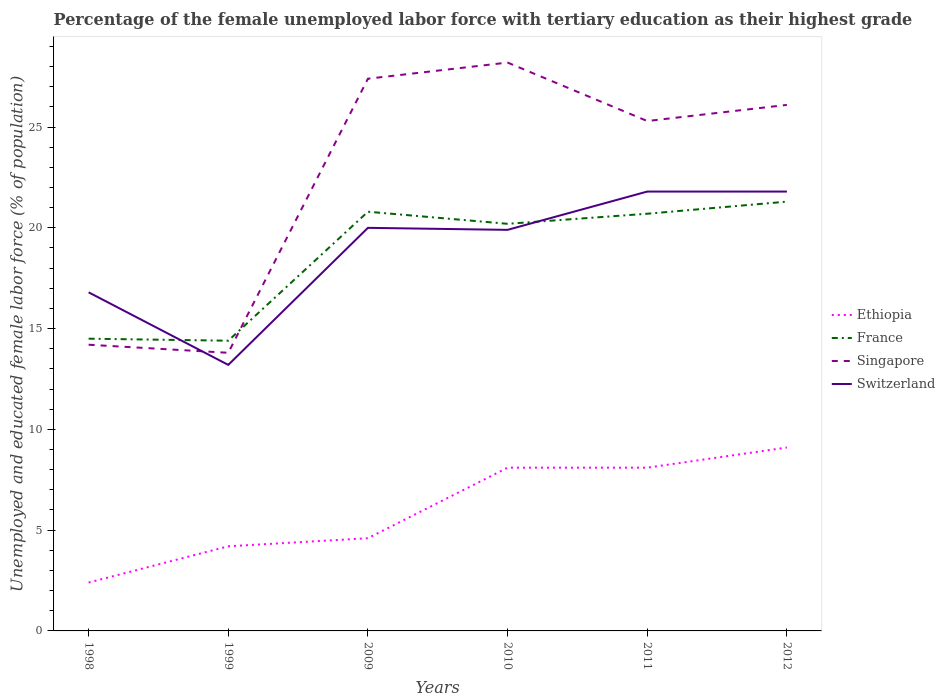Is the number of lines equal to the number of legend labels?
Ensure brevity in your answer.  Yes. Across all years, what is the maximum percentage of the unemployed female labor force with tertiary education in Singapore?
Give a very brief answer. 13.8. What is the total percentage of the unemployed female labor force with tertiary education in France in the graph?
Your answer should be compact. 0.6. What is the difference between the highest and the second highest percentage of the unemployed female labor force with tertiary education in Ethiopia?
Provide a succinct answer. 6.7. Is the percentage of the unemployed female labor force with tertiary education in Singapore strictly greater than the percentage of the unemployed female labor force with tertiary education in France over the years?
Provide a short and direct response. No. What is the difference between two consecutive major ticks on the Y-axis?
Give a very brief answer. 5. How many legend labels are there?
Make the answer very short. 4. How are the legend labels stacked?
Keep it short and to the point. Vertical. What is the title of the graph?
Provide a short and direct response. Percentage of the female unemployed labor force with tertiary education as their highest grade. Does "Mali" appear as one of the legend labels in the graph?
Your answer should be compact. No. What is the label or title of the X-axis?
Your response must be concise. Years. What is the label or title of the Y-axis?
Offer a terse response. Unemployed and educated female labor force (% of population). What is the Unemployed and educated female labor force (% of population) of Ethiopia in 1998?
Offer a terse response. 2.4. What is the Unemployed and educated female labor force (% of population) in France in 1998?
Offer a terse response. 14.5. What is the Unemployed and educated female labor force (% of population) in Singapore in 1998?
Your answer should be compact. 14.2. What is the Unemployed and educated female labor force (% of population) of Switzerland in 1998?
Make the answer very short. 16.8. What is the Unemployed and educated female labor force (% of population) of Ethiopia in 1999?
Your answer should be very brief. 4.2. What is the Unemployed and educated female labor force (% of population) in France in 1999?
Provide a succinct answer. 14.4. What is the Unemployed and educated female labor force (% of population) of Singapore in 1999?
Offer a very short reply. 13.8. What is the Unemployed and educated female labor force (% of population) of Switzerland in 1999?
Provide a succinct answer. 13.2. What is the Unemployed and educated female labor force (% of population) of Ethiopia in 2009?
Your answer should be very brief. 4.6. What is the Unemployed and educated female labor force (% of population) in France in 2009?
Keep it short and to the point. 20.8. What is the Unemployed and educated female labor force (% of population) in Singapore in 2009?
Your answer should be very brief. 27.4. What is the Unemployed and educated female labor force (% of population) of Switzerland in 2009?
Your answer should be compact. 20. What is the Unemployed and educated female labor force (% of population) in Ethiopia in 2010?
Ensure brevity in your answer.  8.1. What is the Unemployed and educated female labor force (% of population) in France in 2010?
Make the answer very short. 20.2. What is the Unemployed and educated female labor force (% of population) of Singapore in 2010?
Offer a very short reply. 28.2. What is the Unemployed and educated female labor force (% of population) of Switzerland in 2010?
Offer a very short reply. 19.9. What is the Unemployed and educated female labor force (% of population) of Ethiopia in 2011?
Provide a short and direct response. 8.1. What is the Unemployed and educated female labor force (% of population) of France in 2011?
Provide a short and direct response. 20.7. What is the Unemployed and educated female labor force (% of population) of Singapore in 2011?
Ensure brevity in your answer.  25.3. What is the Unemployed and educated female labor force (% of population) of Switzerland in 2011?
Keep it short and to the point. 21.8. What is the Unemployed and educated female labor force (% of population) of Ethiopia in 2012?
Provide a short and direct response. 9.1. What is the Unemployed and educated female labor force (% of population) in France in 2012?
Offer a very short reply. 21.3. What is the Unemployed and educated female labor force (% of population) in Singapore in 2012?
Keep it short and to the point. 26.1. What is the Unemployed and educated female labor force (% of population) in Switzerland in 2012?
Provide a succinct answer. 21.8. Across all years, what is the maximum Unemployed and educated female labor force (% of population) in Ethiopia?
Offer a very short reply. 9.1. Across all years, what is the maximum Unemployed and educated female labor force (% of population) in France?
Offer a terse response. 21.3. Across all years, what is the maximum Unemployed and educated female labor force (% of population) in Singapore?
Make the answer very short. 28.2. Across all years, what is the maximum Unemployed and educated female labor force (% of population) in Switzerland?
Provide a succinct answer. 21.8. Across all years, what is the minimum Unemployed and educated female labor force (% of population) in Ethiopia?
Offer a very short reply. 2.4. Across all years, what is the minimum Unemployed and educated female labor force (% of population) of France?
Provide a succinct answer. 14.4. Across all years, what is the minimum Unemployed and educated female labor force (% of population) in Singapore?
Offer a very short reply. 13.8. Across all years, what is the minimum Unemployed and educated female labor force (% of population) of Switzerland?
Your answer should be very brief. 13.2. What is the total Unemployed and educated female labor force (% of population) of Ethiopia in the graph?
Give a very brief answer. 36.5. What is the total Unemployed and educated female labor force (% of population) of France in the graph?
Ensure brevity in your answer.  111.9. What is the total Unemployed and educated female labor force (% of population) in Singapore in the graph?
Ensure brevity in your answer.  135. What is the total Unemployed and educated female labor force (% of population) of Switzerland in the graph?
Ensure brevity in your answer.  113.5. What is the difference between the Unemployed and educated female labor force (% of population) of Ethiopia in 1998 and that in 1999?
Ensure brevity in your answer.  -1.8. What is the difference between the Unemployed and educated female labor force (% of population) of Ethiopia in 1998 and that in 2009?
Ensure brevity in your answer.  -2.2. What is the difference between the Unemployed and educated female labor force (% of population) in France in 1998 and that in 2009?
Your answer should be very brief. -6.3. What is the difference between the Unemployed and educated female labor force (% of population) of Switzerland in 1998 and that in 2009?
Your answer should be very brief. -3.2. What is the difference between the Unemployed and educated female labor force (% of population) in Ethiopia in 1998 and that in 2010?
Give a very brief answer. -5.7. What is the difference between the Unemployed and educated female labor force (% of population) in France in 1998 and that in 2010?
Provide a succinct answer. -5.7. What is the difference between the Unemployed and educated female labor force (% of population) of Switzerland in 1998 and that in 2010?
Make the answer very short. -3.1. What is the difference between the Unemployed and educated female labor force (% of population) in Ethiopia in 1998 and that in 2011?
Keep it short and to the point. -5.7. What is the difference between the Unemployed and educated female labor force (% of population) in Singapore in 1998 and that in 2011?
Offer a very short reply. -11.1. What is the difference between the Unemployed and educated female labor force (% of population) of Singapore in 1998 and that in 2012?
Provide a succinct answer. -11.9. What is the difference between the Unemployed and educated female labor force (% of population) of Ethiopia in 1999 and that in 2009?
Your answer should be very brief. -0.4. What is the difference between the Unemployed and educated female labor force (% of population) in France in 1999 and that in 2009?
Give a very brief answer. -6.4. What is the difference between the Unemployed and educated female labor force (% of population) of Singapore in 1999 and that in 2009?
Offer a very short reply. -13.6. What is the difference between the Unemployed and educated female labor force (% of population) of Ethiopia in 1999 and that in 2010?
Provide a short and direct response. -3.9. What is the difference between the Unemployed and educated female labor force (% of population) of Singapore in 1999 and that in 2010?
Offer a very short reply. -14.4. What is the difference between the Unemployed and educated female labor force (% of population) in Singapore in 1999 and that in 2011?
Keep it short and to the point. -11.5. What is the difference between the Unemployed and educated female labor force (% of population) in France in 1999 and that in 2012?
Your answer should be compact. -6.9. What is the difference between the Unemployed and educated female labor force (% of population) of Switzerland in 1999 and that in 2012?
Give a very brief answer. -8.6. What is the difference between the Unemployed and educated female labor force (% of population) of Ethiopia in 2009 and that in 2010?
Offer a terse response. -3.5. What is the difference between the Unemployed and educated female labor force (% of population) of France in 2009 and that in 2010?
Your response must be concise. 0.6. What is the difference between the Unemployed and educated female labor force (% of population) of Switzerland in 2009 and that in 2010?
Keep it short and to the point. 0.1. What is the difference between the Unemployed and educated female labor force (% of population) in Ethiopia in 2009 and that in 2011?
Provide a succinct answer. -3.5. What is the difference between the Unemployed and educated female labor force (% of population) of Singapore in 2009 and that in 2011?
Offer a very short reply. 2.1. What is the difference between the Unemployed and educated female labor force (% of population) of Switzerland in 2009 and that in 2011?
Provide a short and direct response. -1.8. What is the difference between the Unemployed and educated female labor force (% of population) of Ethiopia in 2009 and that in 2012?
Ensure brevity in your answer.  -4.5. What is the difference between the Unemployed and educated female labor force (% of population) of France in 2009 and that in 2012?
Offer a terse response. -0.5. What is the difference between the Unemployed and educated female labor force (% of population) of Singapore in 2009 and that in 2012?
Offer a very short reply. 1.3. What is the difference between the Unemployed and educated female labor force (% of population) in Ethiopia in 2010 and that in 2011?
Your answer should be compact. 0. What is the difference between the Unemployed and educated female labor force (% of population) of France in 2010 and that in 2011?
Ensure brevity in your answer.  -0.5. What is the difference between the Unemployed and educated female labor force (% of population) of Switzerland in 2010 and that in 2011?
Keep it short and to the point. -1.9. What is the difference between the Unemployed and educated female labor force (% of population) in Singapore in 2010 and that in 2012?
Provide a short and direct response. 2.1. What is the difference between the Unemployed and educated female labor force (% of population) of Switzerland in 2011 and that in 2012?
Provide a succinct answer. 0. What is the difference between the Unemployed and educated female labor force (% of population) of Singapore in 1998 and the Unemployed and educated female labor force (% of population) of Switzerland in 1999?
Offer a very short reply. 1. What is the difference between the Unemployed and educated female labor force (% of population) in Ethiopia in 1998 and the Unemployed and educated female labor force (% of population) in France in 2009?
Offer a terse response. -18.4. What is the difference between the Unemployed and educated female labor force (% of population) of Ethiopia in 1998 and the Unemployed and educated female labor force (% of population) of Switzerland in 2009?
Ensure brevity in your answer.  -17.6. What is the difference between the Unemployed and educated female labor force (% of population) of Ethiopia in 1998 and the Unemployed and educated female labor force (% of population) of France in 2010?
Keep it short and to the point. -17.8. What is the difference between the Unemployed and educated female labor force (% of population) of Ethiopia in 1998 and the Unemployed and educated female labor force (% of population) of Singapore in 2010?
Your answer should be very brief. -25.8. What is the difference between the Unemployed and educated female labor force (% of population) of Ethiopia in 1998 and the Unemployed and educated female labor force (% of population) of Switzerland in 2010?
Give a very brief answer. -17.5. What is the difference between the Unemployed and educated female labor force (% of population) in France in 1998 and the Unemployed and educated female labor force (% of population) in Singapore in 2010?
Give a very brief answer. -13.7. What is the difference between the Unemployed and educated female labor force (% of population) in Singapore in 1998 and the Unemployed and educated female labor force (% of population) in Switzerland in 2010?
Ensure brevity in your answer.  -5.7. What is the difference between the Unemployed and educated female labor force (% of population) of Ethiopia in 1998 and the Unemployed and educated female labor force (% of population) of France in 2011?
Keep it short and to the point. -18.3. What is the difference between the Unemployed and educated female labor force (% of population) of Ethiopia in 1998 and the Unemployed and educated female labor force (% of population) of Singapore in 2011?
Keep it short and to the point. -22.9. What is the difference between the Unemployed and educated female labor force (% of population) in Ethiopia in 1998 and the Unemployed and educated female labor force (% of population) in Switzerland in 2011?
Your answer should be compact. -19.4. What is the difference between the Unemployed and educated female labor force (% of population) in France in 1998 and the Unemployed and educated female labor force (% of population) in Singapore in 2011?
Ensure brevity in your answer.  -10.8. What is the difference between the Unemployed and educated female labor force (% of population) in France in 1998 and the Unemployed and educated female labor force (% of population) in Switzerland in 2011?
Your response must be concise. -7.3. What is the difference between the Unemployed and educated female labor force (% of population) of Ethiopia in 1998 and the Unemployed and educated female labor force (% of population) of France in 2012?
Offer a very short reply. -18.9. What is the difference between the Unemployed and educated female labor force (% of population) in Ethiopia in 1998 and the Unemployed and educated female labor force (% of population) in Singapore in 2012?
Your response must be concise. -23.7. What is the difference between the Unemployed and educated female labor force (% of population) of Ethiopia in 1998 and the Unemployed and educated female labor force (% of population) of Switzerland in 2012?
Offer a terse response. -19.4. What is the difference between the Unemployed and educated female labor force (% of population) of Ethiopia in 1999 and the Unemployed and educated female labor force (% of population) of France in 2009?
Give a very brief answer. -16.6. What is the difference between the Unemployed and educated female labor force (% of population) in Ethiopia in 1999 and the Unemployed and educated female labor force (% of population) in Singapore in 2009?
Give a very brief answer. -23.2. What is the difference between the Unemployed and educated female labor force (% of population) of Ethiopia in 1999 and the Unemployed and educated female labor force (% of population) of Switzerland in 2009?
Your response must be concise. -15.8. What is the difference between the Unemployed and educated female labor force (% of population) of France in 1999 and the Unemployed and educated female labor force (% of population) of Singapore in 2009?
Ensure brevity in your answer.  -13. What is the difference between the Unemployed and educated female labor force (% of population) of Singapore in 1999 and the Unemployed and educated female labor force (% of population) of Switzerland in 2009?
Keep it short and to the point. -6.2. What is the difference between the Unemployed and educated female labor force (% of population) in Ethiopia in 1999 and the Unemployed and educated female labor force (% of population) in Singapore in 2010?
Offer a terse response. -24. What is the difference between the Unemployed and educated female labor force (% of population) of Ethiopia in 1999 and the Unemployed and educated female labor force (% of population) of Switzerland in 2010?
Give a very brief answer. -15.7. What is the difference between the Unemployed and educated female labor force (% of population) of France in 1999 and the Unemployed and educated female labor force (% of population) of Singapore in 2010?
Your answer should be compact. -13.8. What is the difference between the Unemployed and educated female labor force (% of population) in Ethiopia in 1999 and the Unemployed and educated female labor force (% of population) in France in 2011?
Provide a succinct answer. -16.5. What is the difference between the Unemployed and educated female labor force (% of population) of Ethiopia in 1999 and the Unemployed and educated female labor force (% of population) of Singapore in 2011?
Your answer should be very brief. -21.1. What is the difference between the Unemployed and educated female labor force (% of population) of Ethiopia in 1999 and the Unemployed and educated female labor force (% of population) of Switzerland in 2011?
Provide a short and direct response. -17.6. What is the difference between the Unemployed and educated female labor force (% of population) of France in 1999 and the Unemployed and educated female labor force (% of population) of Singapore in 2011?
Make the answer very short. -10.9. What is the difference between the Unemployed and educated female labor force (% of population) in France in 1999 and the Unemployed and educated female labor force (% of population) in Switzerland in 2011?
Provide a succinct answer. -7.4. What is the difference between the Unemployed and educated female labor force (% of population) of Singapore in 1999 and the Unemployed and educated female labor force (% of population) of Switzerland in 2011?
Your response must be concise. -8. What is the difference between the Unemployed and educated female labor force (% of population) in Ethiopia in 1999 and the Unemployed and educated female labor force (% of population) in France in 2012?
Give a very brief answer. -17.1. What is the difference between the Unemployed and educated female labor force (% of population) of Ethiopia in 1999 and the Unemployed and educated female labor force (% of population) of Singapore in 2012?
Keep it short and to the point. -21.9. What is the difference between the Unemployed and educated female labor force (% of population) in Ethiopia in 1999 and the Unemployed and educated female labor force (% of population) in Switzerland in 2012?
Give a very brief answer. -17.6. What is the difference between the Unemployed and educated female labor force (% of population) in France in 1999 and the Unemployed and educated female labor force (% of population) in Switzerland in 2012?
Keep it short and to the point. -7.4. What is the difference between the Unemployed and educated female labor force (% of population) of Ethiopia in 2009 and the Unemployed and educated female labor force (% of population) of France in 2010?
Ensure brevity in your answer.  -15.6. What is the difference between the Unemployed and educated female labor force (% of population) of Ethiopia in 2009 and the Unemployed and educated female labor force (% of population) of Singapore in 2010?
Your response must be concise. -23.6. What is the difference between the Unemployed and educated female labor force (% of population) in Ethiopia in 2009 and the Unemployed and educated female labor force (% of population) in Switzerland in 2010?
Offer a very short reply. -15.3. What is the difference between the Unemployed and educated female labor force (% of population) in France in 2009 and the Unemployed and educated female labor force (% of population) in Singapore in 2010?
Give a very brief answer. -7.4. What is the difference between the Unemployed and educated female labor force (% of population) of Singapore in 2009 and the Unemployed and educated female labor force (% of population) of Switzerland in 2010?
Your response must be concise. 7.5. What is the difference between the Unemployed and educated female labor force (% of population) in Ethiopia in 2009 and the Unemployed and educated female labor force (% of population) in France in 2011?
Your answer should be very brief. -16.1. What is the difference between the Unemployed and educated female labor force (% of population) of Ethiopia in 2009 and the Unemployed and educated female labor force (% of population) of Singapore in 2011?
Offer a very short reply. -20.7. What is the difference between the Unemployed and educated female labor force (% of population) in Ethiopia in 2009 and the Unemployed and educated female labor force (% of population) in Switzerland in 2011?
Keep it short and to the point. -17.2. What is the difference between the Unemployed and educated female labor force (% of population) of France in 2009 and the Unemployed and educated female labor force (% of population) of Singapore in 2011?
Provide a short and direct response. -4.5. What is the difference between the Unemployed and educated female labor force (% of population) of France in 2009 and the Unemployed and educated female labor force (% of population) of Switzerland in 2011?
Make the answer very short. -1. What is the difference between the Unemployed and educated female labor force (% of population) in Singapore in 2009 and the Unemployed and educated female labor force (% of population) in Switzerland in 2011?
Your answer should be very brief. 5.6. What is the difference between the Unemployed and educated female labor force (% of population) of Ethiopia in 2009 and the Unemployed and educated female labor force (% of population) of France in 2012?
Offer a terse response. -16.7. What is the difference between the Unemployed and educated female labor force (% of population) in Ethiopia in 2009 and the Unemployed and educated female labor force (% of population) in Singapore in 2012?
Provide a short and direct response. -21.5. What is the difference between the Unemployed and educated female labor force (% of population) of Ethiopia in 2009 and the Unemployed and educated female labor force (% of population) of Switzerland in 2012?
Offer a very short reply. -17.2. What is the difference between the Unemployed and educated female labor force (% of population) in Singapore in 2009 and the Unemployed and educated female labor force (% of population) in Switzerland in 2012?
Offer a very short reply. 5.6. What is the difference between the Unemployed and educated female labor force (% of population) of Ethiopia in 2010 and the Unemployed and educated female labor force (% of population) of Singapore in 2011?
Ensure brevity in your answer.  -17.2. What is the difference between the Unemployed and educated female labor force (% of population) of Ethiopia in 2010 and the Unemployed and educated female labor force (% of population) of Switzerland in 2011?
Your answer should be compact. -13.7. What is the difference between the Unemployed and educated female labor force (% of population) of Singapore in 2010 and the Unemployed and educated female labor force (% of population) of Switzerland in 2011?
Your answer should be compact. 6.4. What is the difference between the Unemployed and educated female labor force (% of population) of Ethiopia in 2010 and the Unemployed and educated female labor force (% of population) of France in 2012?
Offer a terse response. -13.2. What is the difference between the Unemployed and educated female labor force (% of population) of Ethiopia in 2010 and the Unemployed and educated female labor force (% of population) of Singapore in 2012?
Keep it short and to the point. -18. What is the difference between the Unemployed and educated female labor force (% of population) in Ethiopia in 2010 and the Unemployed and educated female labor force (% of population) in Switzerland in 2012?
Your response must be concise. -13.7. What is the difference between the Unemployed and educated female labor force (% of population) of France in 2010 and the Unemployed and educated female labor force (% of population) of Switzerland in 2012?
Offer a very short reply. -1.6. What is the difference between the Unemployed and educated female labor force (% of population) in Ethiopia in 2011 and the Unemployed and educated female labor force (% of population) in France in 2012?
Provide a short and direct response. -13.2. What is the difference between the Unemployed and educated female labor force (% of population) of Ethiopia in 2011 and the Unemployed and educated female labor force (% of population) of Switzerland in 2012?
Give a very brief answer. -13.7. What is the average Unemployed and educated female labor force (% of population) in Ethiopia per year?
Provide a succinct answer. 6.08. What is the average Unemployed and educated female labor force (% of population) in France per year?
Ensure brevity in your answer.  18.65. What is the average Unemployed and educated female labor force (% of population) in Singapore per year?
Your answer should be very brief. 22.5. What is the average Unemployed and educated female labor force (% of population) in Switzerland per year?
Offer a terse response. 18.92. In the year 1998, what is the difference between the Unemployed and educated female labor force (% of population) of Ethiopia and Unemployed and educated female labor force (% of population) of Singapore?
Offer a very short reply. -11.8. In the year 1998, what is the difference between the Unemployed and educated female labor force (% of population) of Ethiopia and Unemployed and educated female labor force (% of population) of Switzerland?
Ensure brevity in your answer.  -14.4. In the year 1998, what is the difference between the Unemployed and educated female labor force (% of population) in France and Unemployed and educated female labor force (% of population) in Singapore?
Your answer should be very brief. 0.3. In the year 1998, what is the difference between the Unemployed and educated female labor force (% of population) of Singapore and Unemployed and educated female labor force (% of population) of Switzerland?
Ensure brevity in your answer.  -2.6. In the year 1999, what is the difference between the Unemployed and educated female labor force (% of population) in Singapore and Unemployed and educated female labor force (% of population) in Switzerland?
Provide a succinct answer. 0.6. In the year 2009, what is the difference between the Unemployed and educated female labor force (% of population) in Ethiopia and Unemployed and educated female labor force (% of population) in France?
Make the answer very short. -16.2. In the year 2009, what is the difference between the Unemployed and educated female labor force (% of population) of Ethiopia and Unemployed and educated female labor force (% of population) of Singapore?
Provide a short and direct response. -22.8. In the year 2009, what is the difference between the Unemployed and educated female labor force (% of population) of Ethiopia and Unemployed and educated female labor force (% of population) of Switzerland?
Ensure brevity in your answer.  -15.4. In the year 2009, what is the difference between the Unemployed and educated female labor force (% of population) in France and Unemployed and educated female labor force (% of population) in Singapore?
Make the answer very short. -6.6. In the year 2009, what is the difference between the Unemployed and educated female labor force (% of population) of France and Unemployed and educated female labor force (% of population) of Switzerland?
Ensure brevity in your answer.  0.8. In the year 2010, what is the difference between the Unemployed and educated female labor force (% of population) in Ethiopia and Unemployed and educated female labor force (% of population) in France?
Your answer should be very brief. -12.1. In the year 2010, what is the difference between the Unemployed and educated female labor force (% of population) of Ethiopia and Unemployed and educated female labor force (% of population) of Singapore?
Make the answer very short. -20.1. In the year 2011, what is the difference between the Unemployed and educated female labor force (% of population) in Ethiopia and Unemployed and educated female labor force (% of population) in Singapore?
Provide a short and direct response. -17.2. In the year 2011, what is the difference between the Unemployed and educated female labor force (% of population) of Ethiopia and Unemployed and educated female labor force (% of population) of Switzerland?
Offer a terse response. -13.7. In the year 2011, what is the difference between the Unemployed and educated female labor force (% of population) in France and Unemployed and educated female labor force (% of population) in Singapore?
Keep it short and to the point. -4.6. In the year 2011, what is the difference between the Unemployed and educated female labor force (% of population) of Singapore and Unemployed and educated female labor force (% of population) of Switzerland?
Your response must be concise. 3.5. In the year 2012, what is the difference between the Unemployed and educated female labor force (% of population) in Ethiopia and Unemployed and educated female labor force (% of population) in Singapore?
Your answer should be very brief. -17. In the year 2012, what is the difference between the Unemployed and educated female labor force (% of population) of Ethiopia and Unemployed and educated female labor force (% of population) of Switzerland?
Your answer should be compact. -12.7. In the year 2012, what is the difference between the Unemployed and educated female labor force (% of population) of France and Unemployed and educated female labor force (% of population) of Switzerland?
Your answer should be very brief. -0.5. In the year 2012, what is the difference between the Unemployed and educated female labor force (% of population) of Singapore and Unemployed and educated female labor force (% of population) of Switzerland?
Offer a very short reply. 4.3. What is the ratio of the Unemployed and educated female labor force (% of population) of Switzerland in 1998 to that in 1999?
Keep it short and to the point. 1.27. What is the ratio of the Unemployed and educated female labor force (% of population) of Ethiopia in 1998 to that in 2009?
Offer a very short reply. 0.52. What is the ratio of the Unemployed and educated female labor force (% of population) of France in 1998 to that in 2009?
Provide a short and direct response. 0.7. What is the ratio of the Unemployed and educated female labor force (% of population) of Singapore in 1998 to that in 2009?
Offer a terse response. 0.52. What is the ratio of the Unemployed and educated female labor force (% of population) in Switzerland in 1998 to that in 2009?
Keep it short and to the point. 0.84. What is the ratio of the Unemployed and educated female labor force (% of population) in Ethiopia in 1998 to that in 2010?
Offer a terse response. 0.3. What is the ratio of the Unemployed and educated female labor force (% of population) in France in 1998 to that in 2010?
Offer a terse response. 0.72. What is the ratio of the Unemployed and educated female labor force (% of population) of Singapore in 1998 to that in 2010?
Your response must be concise. 0.5. What is the ratio of the Unemployed and educated female labor force (% of population) in Switzerland in 1998 to that in 2010?
Your answer should be compact. 0.84. What is the ratio of the Unemployed and educated female labor force (% of population) in Ethiopia in 1998 to that in 2011?
Keep it short and to the point. 0.3. What is the ratio of the Unemployed and educated female labor force (% of population) in France in 1998 to that in 2011?
Ensure brevity in your answer.  0.7. What is the ratio of the Unemployed and educated female labor force (% of population) of Singapore in 1998 to that in 2011?
Ensure brevity in your answer.  0.56. What is the ratio of the Unemployed and educated female labor force (% of population) in Switzerland in 1998 to that in 2011?
Provide a succinct answer. 0.77. What is the ratio of the Unemployed and educated female labor force (% of population) of Ethiopia in 1998 to that in 2012?
Keep it short and to the point. 0.26. What is the ratio of the Unemployed and educated female labor force (% of population) of France in 1998 to that in 2012?
Make the answer very short. 0.68. What is the ratio of the Unemployed and educated female labor force (% of population) in Singapore in 1998 to that in 2012?
Your answer should be very brief. 0.54. What is the ratio of the Unemployed and educated female labor force (% of population) in Switzerland in 1998 to that in 2012?
Provide a succinct answer. 0.77. What is the ratio of the Unemployed and educated female labor force (% of population) of France in 1999 to that in 2009?
Give a very brief answer. 0.69. What is the ratio of the Unemployed and educated female labor force (% of population) of Singapore in 1999 to that in 2009?
Offer a very short reply. 0.5. What is the ratio of the Unemployed and educated female labor force (% of population) in Switzerland in 1999 to that in 2009?
Your answer should be very brief. 0.66. What is the ratio of the Unemployed and educated female labor force (% of population) of Ethiopia in 1999 to that in 2010?
Your response must be concise. 0.52. What is the ratio of the Unemployed and educated female labor force (% of population) of France in 1999 to that in 2010?
Offer a very short reply. 0.71. What is the ratio of the Unemployed and educated female labor force (% of population) of Singapore in 1999 to that in 2010?
Ensure brevity in your answer.  0.49. What is the ratio of the Unemployed and educated female labor force (% of population) of Switzerland in 1999 to that in 2010?
Your answer should be compact. 0.66. What is the ratio of the Unemployed and educated female labor force (% of population) of Ethiopia in 1999 to that in 2011?
Ensure brevity in your answer.  0.52. What is the ratio of the Unemployed and educated female labor force (% of population) of France in 1999 to that in 2011?
Give a very brief answer. 0.7. What is the ratio of the Unemployed and educated female labor force (% of population) of Singapore in 1999 to that in 2011?
Provide a short and direct response. 0.55. What is the ratio of the Unemployed and educated female labor force (% of population) of Switzerland in 1999 to that in 2011?
Offer a very short reply. 0.61. What is the ratio of the Unemployed and educated female labor force (% of population) of Ethiopia in 1999 to that in 2012?
Offer a terse response. 0.46. What is the ratio of the Unemployed and educated female labor force (% of population) in France in 1999 to that in 2012?
Your answer should be compact. 0.68. What is the ratio of the Unemployed and educated female labor force (% of population) in Singapore in 1999 to that in 2012?
Ensure brevity in your answer.  0.53. What is the ratio of the Unemployed and educated female labor force (% of population) of Switzerland in 1999 to that in 2012?
Give a very brief answer. 0.61. What is the ratio of the Unemployed and educated female labor force (% of population) of Ethiopia in 2009 to that in 2010?
Ensure brevity in your answer.  0.57. What is the ratio of the Unemployed and educated female labor force (% of population) of France in 2009 to that in 2010?
Ensure brevity in your answer.  1.03. What is the ratio of the Unemployed and educated female labor force (% of population) in Singapore in 2009 to that in 2010?
Provide a short and direct response. 0.97. What is the ratio of the Unemployed and educated female labor force (% of population) in Ethiopia in 2009 to that in 2011?
Provide a succinct answer. 0.57. What is the ratio of the Unemployed and educated female labor force (% of population) in France in 2009 to that in 2011?
Provide a succinct answer. 1. What is the ratio of the Unemployed and educated female labor force (% of population) of Singapore in 2009 to that in 2011?
Offer a terse response. 1.08. What is the ratio of the Unemployed and educated female labor force (% of population) in Switzerland in 2009 to that in 2011?
Offer a very short reply. 0.92. What is the ratio of the Unemployed and educated female labor force (% of population) of Ethiopia in 2009 to that in 2012?
Your response must be concise. 0.51. What is the ratio of the Unemployed and educated female labor force (% of population) in France in 2009 to that in 2012?
Give a very brief answer. 0.98. What is the ratio of the Unemployed and educated female labor force (% of population) of Singapore in 2009 to that in 2012?
Keep it short and to the point. 1.05. What is the ratio of the Unemployed and educated female labor force (% of population) of Switzerland in 2009 to that in 2012?
Give a very brief answer. 0.92. What is the ratio of the Unemployed and educated female labor force (% of population) of Ethiopia in 2010 to that in 2011?
Provide a short and direct response. 1. What is the ratio of the Unemployed and educated female labor force (% of population) in France in 2010 to that in 2011?
Offer a very short reply. 0.98. What is the ratio of the Unemployed and educated female labor force (% of population) in Singapore in 2010 to that in 2011?
Your answer should be very brief. 1.11. What is the ratio of the Unemployed and educated female labor force (% of population) in Switzerland in 2010 to that in 2011?
Offer a very short reply. 0.91. What is the ratio of the Unemployed and educated female labor force (% of population) in Ethiopia in 2010 to that in 2012?
Ensure brevity in your answer.  0.89. What is the ratio of the Unemployed and educated female labor force (% of population) of France in 2010 to that in 2012?
Ensure brevity in your answer.  0.95. What is the ratio of the Unemployed and educated female labor force (% of population) in Singapore in 2010 to that in 2012?
Offer a terse response. 1.08. What is the ratio of the Unemployed and educated female labor force (% of population) of Switzerland in 2010 to that in 2012?
Ensure brevity in your answer.  0.91. What is the ratio of the Unemployed and educated female labor force (% of population) of Ethiopia in 2011 to that in 2012?
Ensure brevity in your answer.  0.89. What is the ratio of the Unemployed and educated female labor force (% of population) in France in 2011 to that in 2012?
Your answer should be compact. 0.97. What is the ratio of the Unemployed and educated female labor force (% of population) of Singapore in 2011 to that in 2012?
Provide a short and direct response. 0.97. What is the ratio of the Unemployed and educated female labor force (% of population) in Switzerland in 2011 to that in 2012?
Your answer should be compact. 1. What is the difference between the highest and the second highest Unemployed and educated female labor force (% of population) in Ethiopia?
Your answer should be very brief. 1. What is the difference between the highest and the second highest Unemployed and educated female labor force (% of population) in France?
Your response must be concise. 0.5. What is the difference between the highest and the second highest Unemployed and educated female labor force (% of population) of Singapore?
Make the answer very short. 0.8. What is the difference between the highest and the lowest Unemployed and educated female labor force (% of population) in Singapore?
Offer a very short reply. 14.4. 